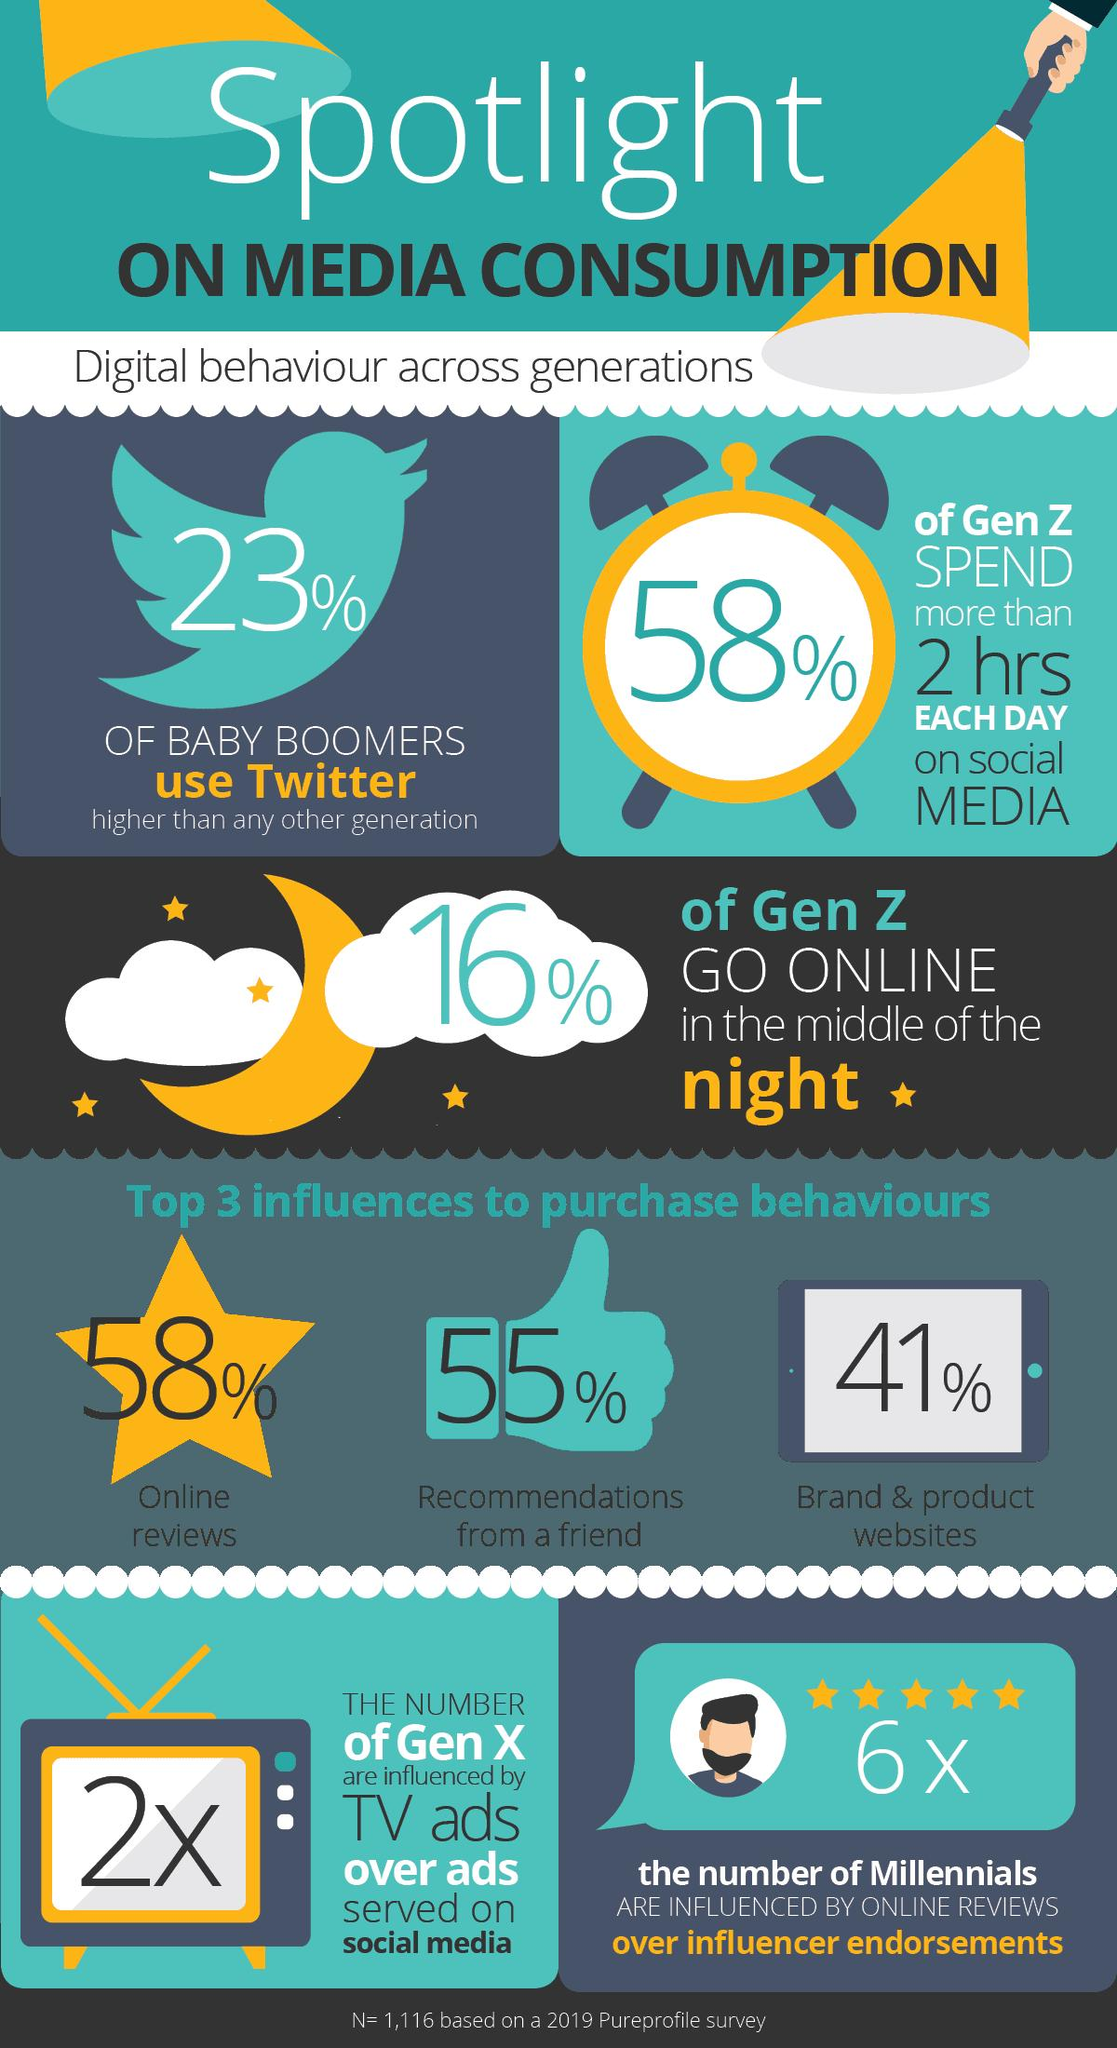Give some essential details in this illustration. The second most significant factor that influences online purchase behavior is recommendations from friends. The second least significant factor that affects online purchase behavior is recommendations from a friend. 